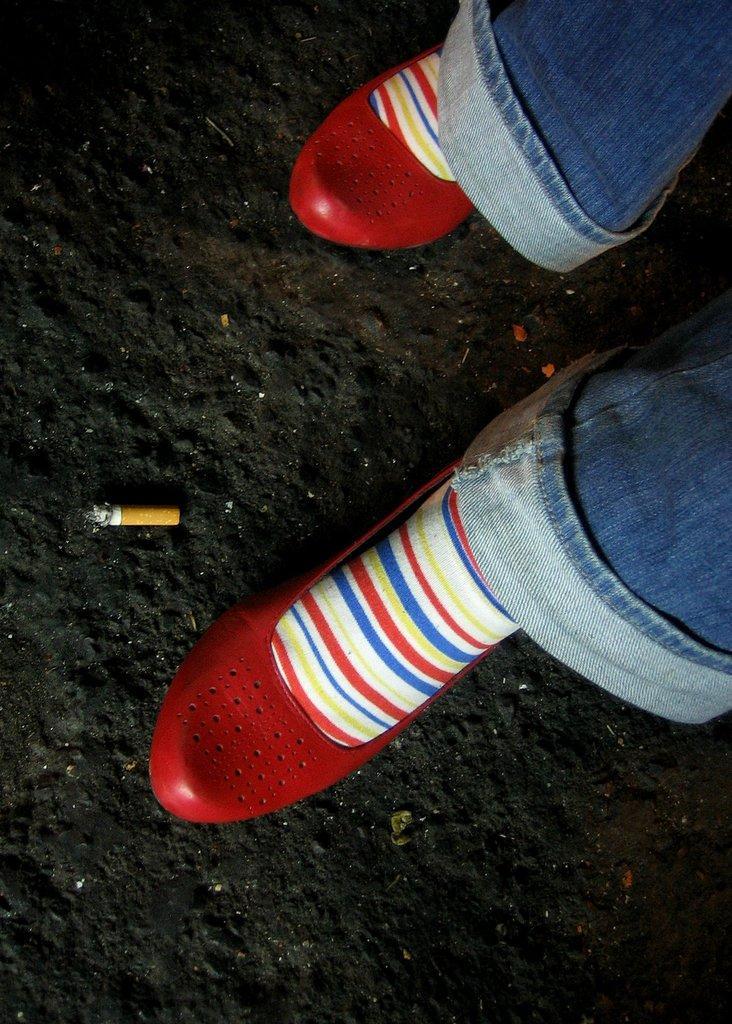Please provide a concise description of this image. This is a zoomed in picture. On the right we can see the legs of a person, wearing jeans, colorful socks and red color shoes and a person seems to be walking on the ground. On the left there is a piece of cigarette lying on the ground. 